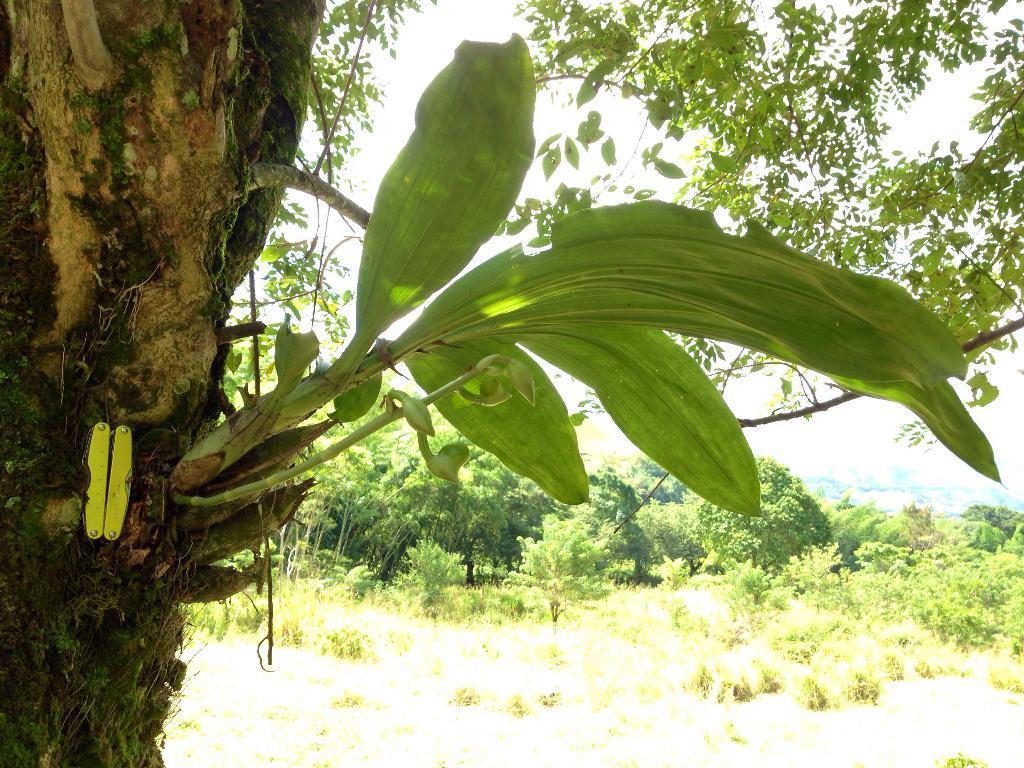Describe this image in one or two sentences. In this image, I can see the trees and plants. On the left side of the image, there is a tree trunk with branches and leaves. In the background, I can see the sky. 